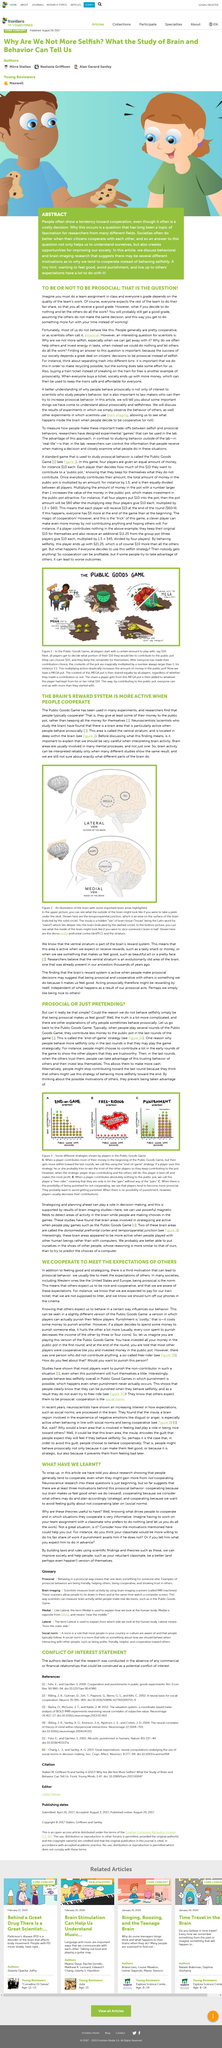Specify some key components in this picture. The motivators of reward, strategy, and social norms are key drivers of non-profit cooperation, encouraging individuals to work together for the greater good. The ventral striatum is the area of the brain that becomes particularly active when people engage in prosocial behaviors. The evidence suggests that societies function better when citizens cooperate. The article discussed the concept of people cooperating and working together even if they do not gain any personal benefit from it. The article does not discuss the motivation for cooperation, which is a significant omission. 